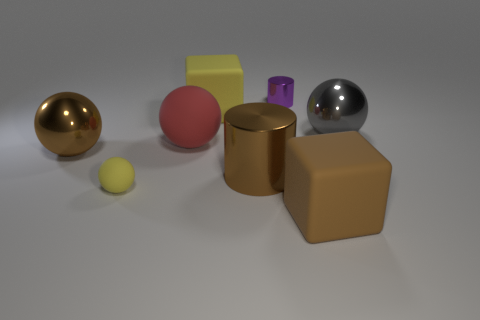There is a shiny thing that is the same color as the big shiny cylinder; what size is it?
Keep it short and to the point. Large. Is there a thing of the same color as the tiny rubber sphere?
Keep it short and to the point. Yes. The object that is the same color as the tiny rubber ball is what shape?
Your answer should be compact. Cube. How many big things are shiny things or brown cubes?
Your answer should be compact. 4. The other metal object that is the same shape as the small metallic object is what color?
Offer a very short reply. Brown. Is the size of the brown matte block the same as the brown cylinder?
Your answer should be very brief. Yes. What number of things are either small cyan shiny balls or large brown objects on the left side of the small shiny thing?
Your answer should be very brief. 2. What color is the large shiny thing behind the large metal ball that is left of the brown rubber thing?
Your answer should be compact. Gray. There is a big rubber block that is on the left side of the brown rubber block; does it have the same color as the small rubber sphere?
Provide a succinct answer. Yes. What is the big sphere left of the tiny yellow ball made of?
Your answer should be compact. Metal. 